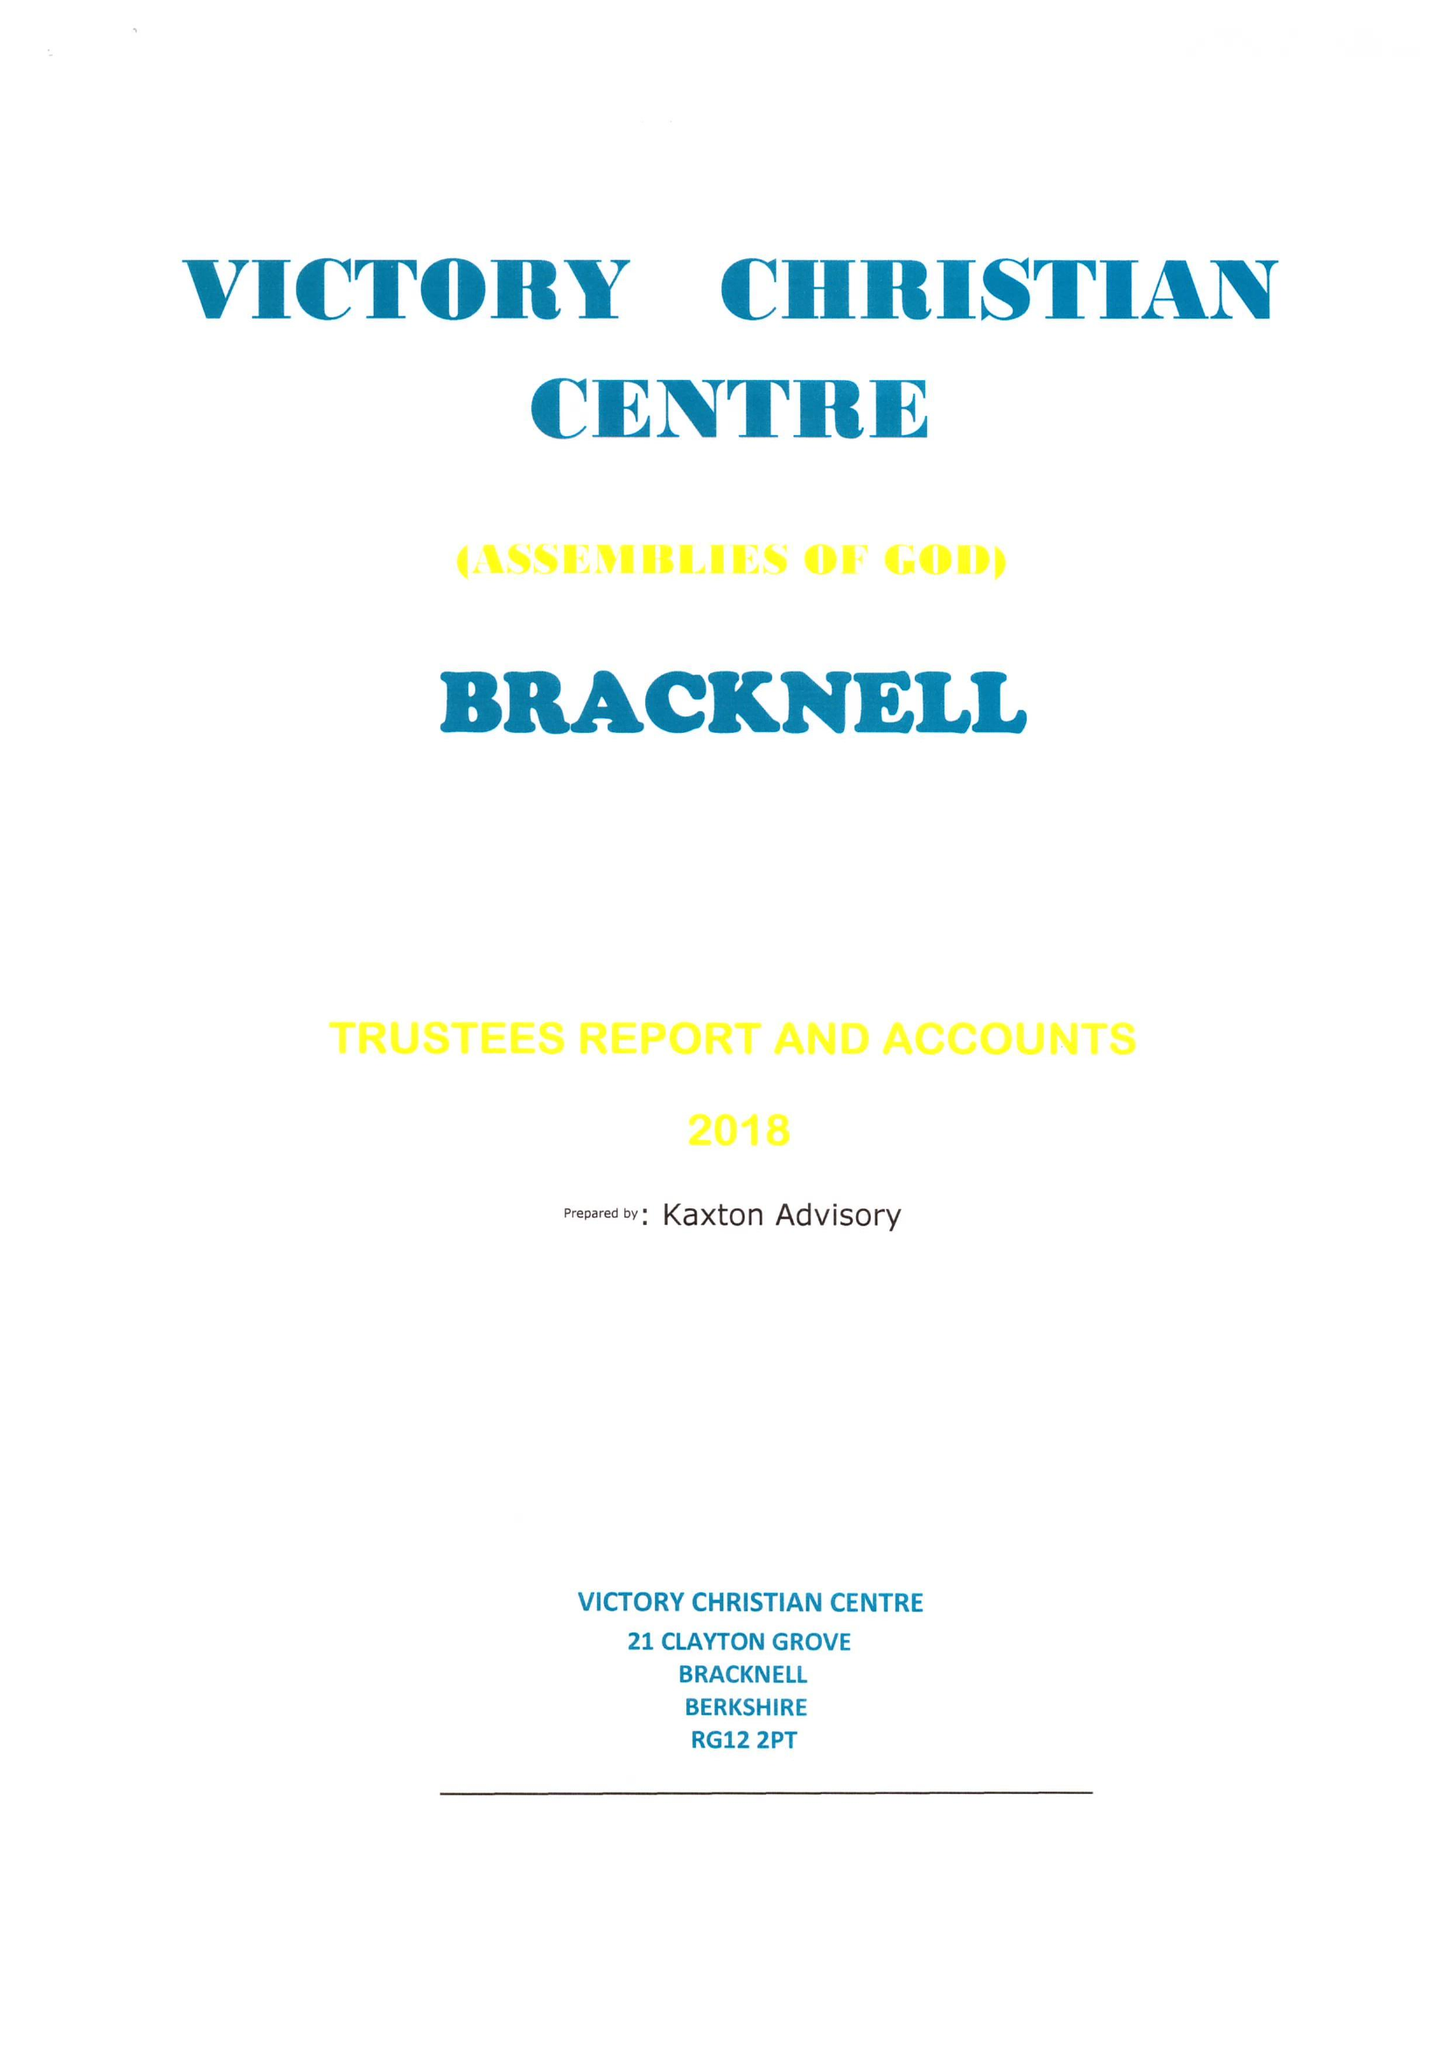What is the value for the report_date?
Answer the question using a single word or phrase. 2018-12-31 